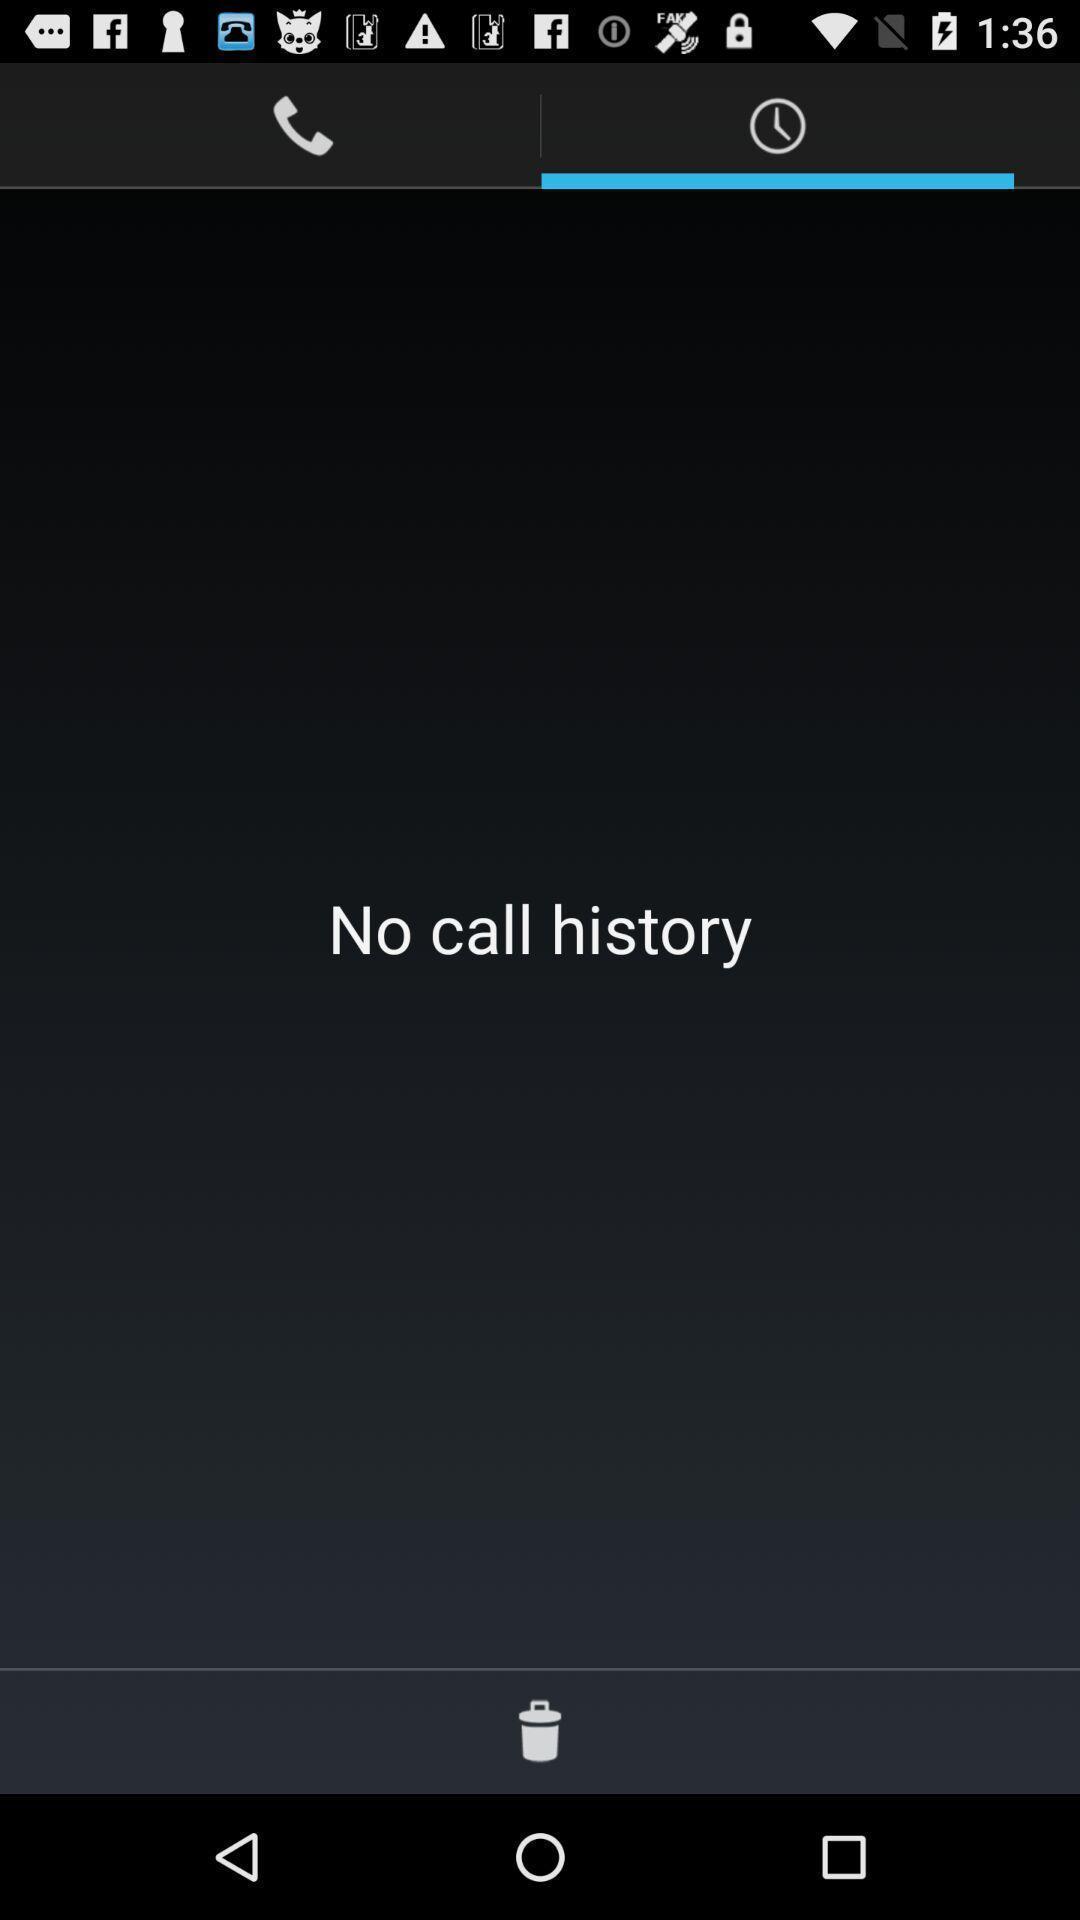What can you discern from this picture? Page shows the empty call history on calling app. 